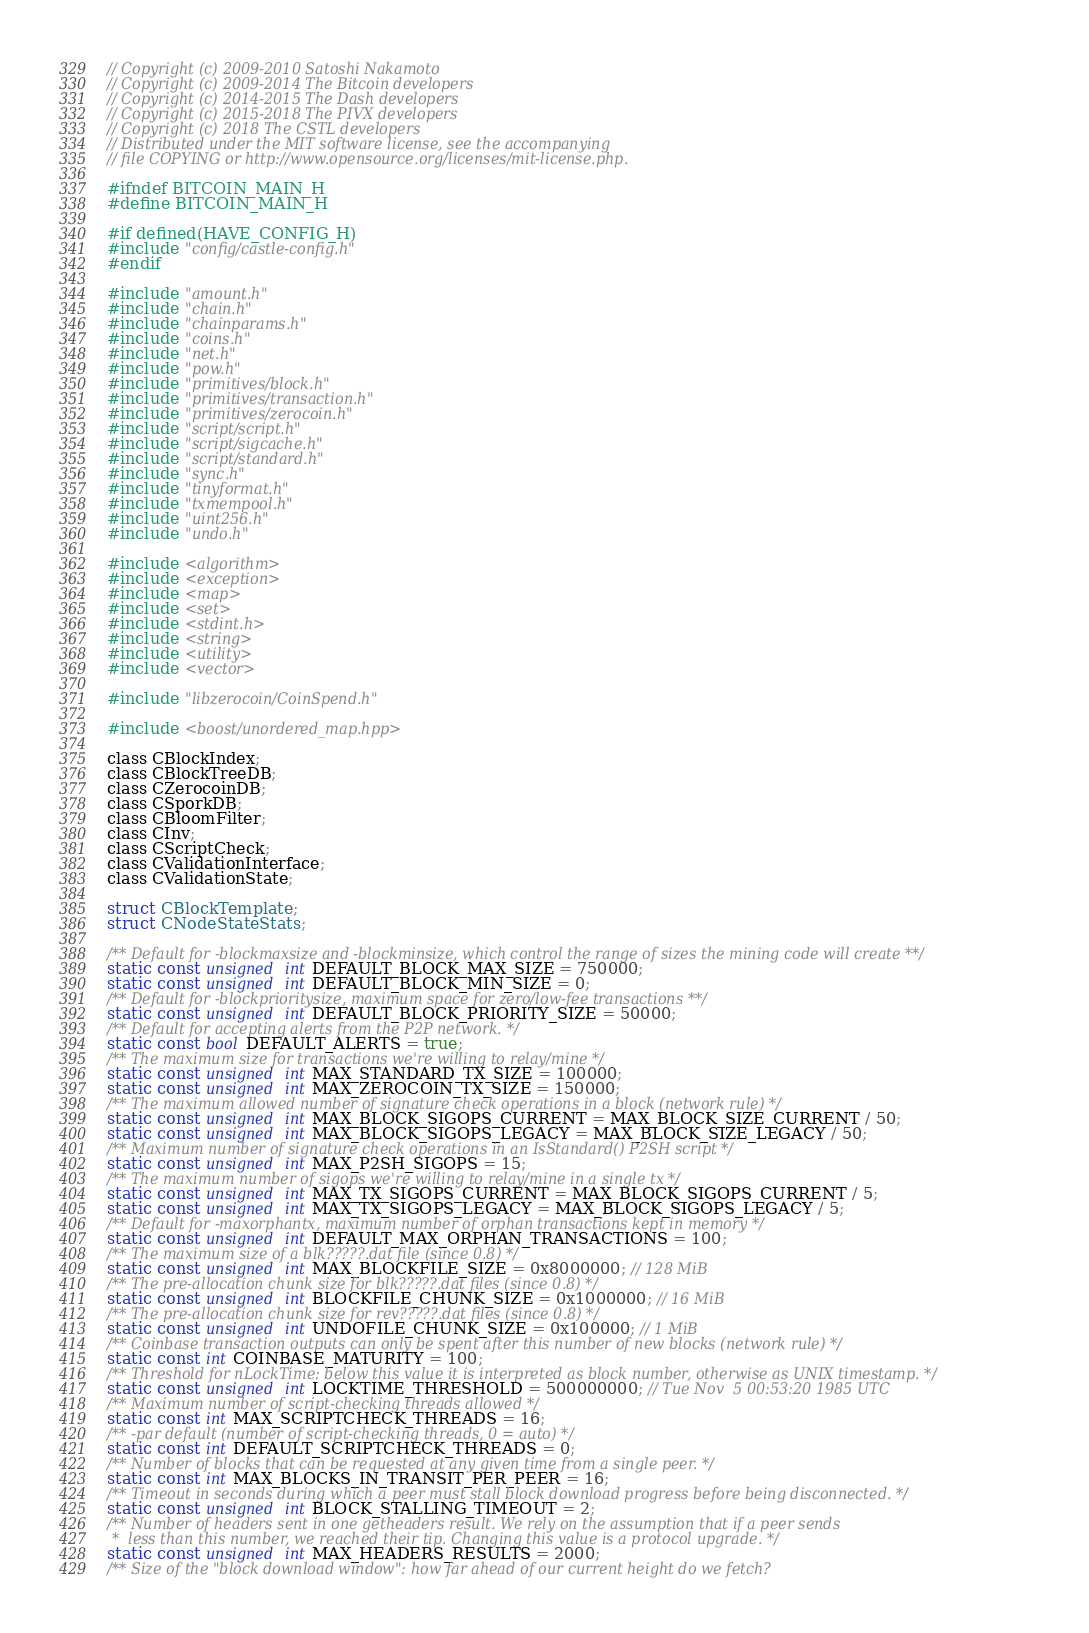<code> <loc_0><loc_0><loc_500><loc_500><_C_>// Copyright (c) 2009-2010 Satoshi Nakamoto
// Copyright (c) 2009-2014 The Bitcoin developers
// Copyright (c) 2014-2015 The Dash developers
// Copyright (c) 2015-2018 The PIVX developers
// Copyright (c) 2018 The CSTL developers
// Distributed under the MIT software license, see the accompanying
// file COPYING or http://www.opensource.org/licenses/mit-license.php.

#ifndef BITCOIN_MAIN_H
#define BITCOIN_MAIN_H

#if defined(HAVE_CONFIG_H)
#include "config/castle-config.h"
#endif

#include "amount.h"
#include "chain.h"
#include "chainparams.h"
#include "coins.h"
#include "net.h"
#include "pow.h"
#include "primitives/block.h"
#include "primitives/transaction.h"
#include "primitives/zerocoin.h"
#include "script/script.h"
#include "script/sigcache.h"
#include "script/standard.h"
#include "sync.h"
#include "tinyformat.h"
#include "txmempool.h"
#include "uint256.h"
#include "undo.h"

#include <algorithm>
#include <exception>
#include <map>
#include <set>
#include <stdint.h>
#include <string>
#include <utility>
#include <vector>

#include "libzerocoin/CoinSpend.h"

#include <boost/unordered_map.hpp>

class CBlockIndex;
class CBlockTreeDB;
class CZerocoinDB;
class CSporkDB;
class CBloomFilter;
class CInv;
class CScriptCheck;
class CValidationInterface;
class CValidationState;

struct CBlockTemplate;
struct CNodeStateStats;

/** Default for -blockmaxsize and -blockminsize, which control the range of sizes the mining code will create **/
static const unsigned int DEFAULT_BLOCK_MAX_SIZE = 750000;
static const unsigned int DEFAULT_BLOCK_MIN_SIZE = 0;
/** Default for -blockprioritysize, maximum space for zero/low-fee transactions **/
static const unsigned int DEFAULT_BLOCK_PRIORITY_SIZE = 50000;
/** Default for accepting alerts from the P2P network. */
static const bool DEFAULT_ALERTS = true;
/** The maximum size for transactions we're willing to relay/mine */
static const unsigned int MAX_STANDARD_TX_SIZE = 100000;
static const unsigned int MAX_ZEROCOIN_TX_SIZE = 150000;
/** The maximum allowed number of signature check operations in a block (network rule) */
static const unsigned int MAX_BLOCK_SIGOPS_CURRENT = MAX_BLOCK_SIZE_CURRENT / 50;
static const unsigned int MAX_BLOCK_SIGOPS_LEGACY = MAX_BLOCK_SIZE_LEGACY / 50;
/** Maximum number of signature check operations in an IsStandard() P2SH script */
static const unsigned int MAX_P2SH_SIGOPS = 15;
/** The maximum number of sigops we're willing to relay/mine in a single tx */
static const unsigned int MAX_TX_SIGOPS_CURRENT = MAX_BLOCK_SIGOPS_CURRENT / 5;
static const unsigned int MAX_TX_SIGOPS_LEGACY = MAX_BLOCK_SIGOPS_LEGACY / 5;
/** Default for -maxorphantx, maximum number of orphan transactions kept in memory */
static const unsigned int DEFAULT_MAX_ORPHAN_TRANSACTIONS = 100;
/** The maximum size of a blk?????.dat file (since 0.8) */
static const unsigned int MAX_BLOCKFILE_SIZE = 0x8000000; // 128 MiB
/** The pre-allocation chunk size for blk?????.dat files (since 0.8) */
static const unsigned int BLOCKFILE_CHUNK_SIZE = 0x1000000; // 16 MiB
/** The pre-allocation chunk size for rev?????.dat files (since 0.8) */
static const unsigned int UNDOFILE_CHUNK_SIZE = 0x100000; // 1 MiB
/** Coinbase transaction outputs can only be spent after this number of new blocks (network rule) */
static const int COINBASE_MATURITY = 100;
/** Threshold for nLockTime: below this value it is interpreted as block number, otherwise as UNIX timestamp. */
static const unsigned int LOCKTIME_THRESHOLD = 500000000; // Tue Nov  5 00:53:20 1985 UTC
/** Maximum number of script-checking threads allowed */
static const int MAX_SCRIPTCHECK_THREADS = 16;
/** -par default (number of script-checking threads, 0 = auto) */
static const int DEFAULT_SCRIPTCHECK_THREADS = 0;
/** Number of blocks that can be requested at any given time from a single peer. */
static const int MAX_BLOCKS_IN_TRANSIT_PER_PEER = 16;
/** Timeout in seconds during which a peer must stall block download progress before being disconnected. */
static const unsigned int BLOCK_STALLING_TIMEOUT = 2;
/** Number of headers sent in one getheaders result. We rely on the assumption that if a peer sends
 *  less than this number, we reached their tip. Changing this value is a protocol upgrade. */
static const unsigned int MAX_HEADERS_RESULTS = 2000;
/** Size of the "block download window": how far ahead of our current height do we fetch?</code> 